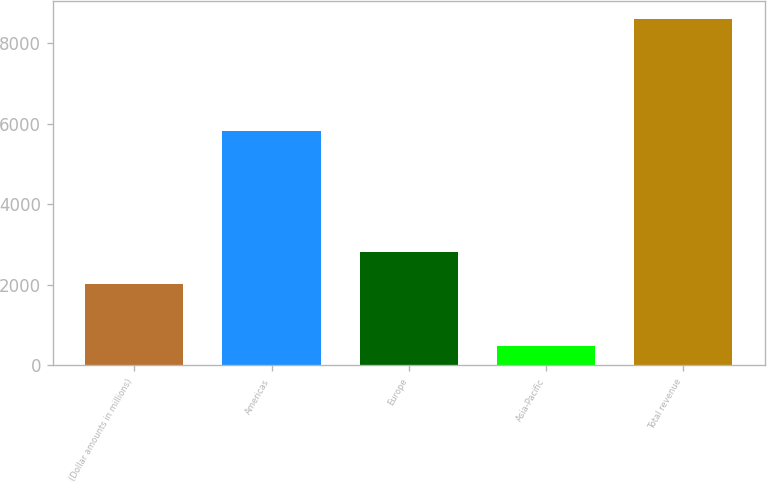<chart> <loc_0><loc_0><loc_500><loc_500><bar_chart><fcel>(Dollar amounts in millions)<fcel>Americas<fcel>Europe<fcel>Asia-Pacific<fcel>Total revenue<nl><fcel>2010<fcel>5824<fcel>2822.4<fcel>488<fcel>8612<nl></chart> 